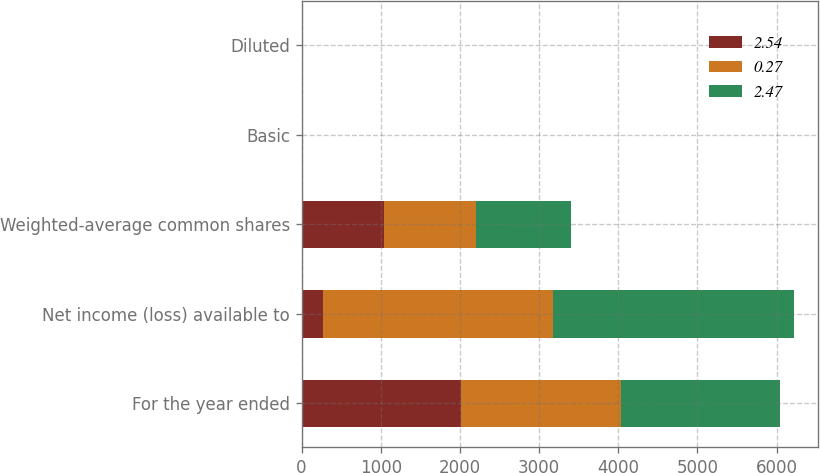Convert chart to OTSL. <chart><loc_0><loc_0><loc_500><loc_500><stacked_bar_chart><ecel><fcel>For the year ended<fcel>Net income (loss) available to<fcel>Weighted-average common shares<fcel>Basic<fcel>Diluted<nl><fcel>2.54<fcel>2016<fcel>276<fcel>1036<fcel>0.27<fcel>0.27<nl><fcel>0.27<fcel>2015<fcel>2896<fcel>1170<fcel>2.71<fcel>2.47<nl><fcel>2.47<fcel>2014<fcel>3043<fcel>1198<fcel>2.87<fcel>2.54<nl></chart> 